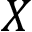Convert formula to latex. <formula><loc_0><loc_0><loc_500><loc_500>X</formula> 